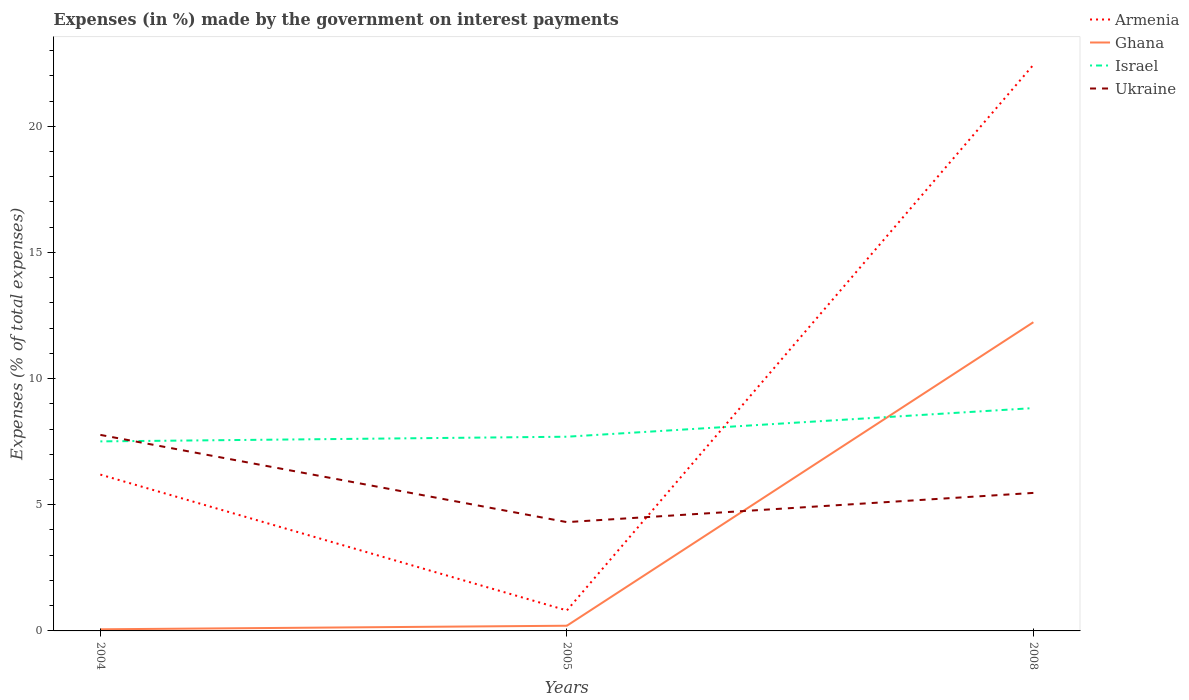How many different coloured lines are there?
Ensure brevity in your answer.  4. Across all years, what is the maximum percentage of expenses made by the government on interest payments in Armenia?
Provide a succinct answer. 0.81. What is the total percentage of expenses made by the government on interest payments in Armenia in the graph?
Provide a short and direct response. -16.24. What is the difference between the highest and the second highest percentage of expenses made by the government on interest payments in Ghana?
Make the answer very short. 12.17. Are the values on the major ticks of Y-axis written in scientific E-notation?
Provide a short and direct response. No. Where does the legend appear in the graph?
Your answer should be very brief. Top right. How many legend labels are there?
Your answer should be very brief. 4. How are the legend labels stacked?
Offer a very short reply. Vertical. What is the title of the graph?
Give a very brief answer. Expenses (in %) made by the government on interest payments. Does "Faeroe Islands" appear as one of the legend labels in the graph?
Make the answer very short. No. What is the label or title of the Y-axis?
Offer a terse response. Expenses (% of total expenses). What is the Expenses (% of total expenses) in Armenia in 2004?
Offer a terse response. 6.2. What is the Expenses (% of total expenses) in Ghana in 2004?
Ensure brevity in your answer.  0.06. What is the Expenses (% of total expenses) in Israel in 2004?
Provide a succinct answer. 7.51. What is the Expenses (% of total expenses) of Ukraine in 2004?
Keep it short and to the point. 7.77. What is the Expenses (% of total expenses) in Armenia in 2005?
Give a very brief answer. 0.81. What is the Expenses (% of total expenses) in Ghana in 2005?
Make the answer very short. 0.21. What is the Expenses (% of total expenses) in Israel in 2005?
Your response must be concise. 7.7. What is the Expenses (% of total expenses) in Ukraine in 2005?
Your response must be concise. 4.31. What is the Expenses (% of total expenses) in Armenia in 2008?
Offer a terse response. 22.44. What is the Expenses (% of total expenses) in Ghana in 2008?
Keep it short and to the point. 12.23. What is the Expenses (% of total expenses) of Israel in 2008?
Provide a short and direct response. 8.83. What is the Expenses (% of total expenses) of Ukraine in 2008?
Your answer should be compact. 5.47. Across all years, what is the maximum Expenses (% of total expenses) of Armenia?
Offer a terse response. 22.44. Across all years, what is the maximum Expenses (% of total expenses) of Ghana?
Keep it short and to the point. 12.23. Across all years, what is the maximum Expenses (% of total expenses) in Israel?
Keep it short and to the point. 8.83. Across all years, what is the maximum Expenses (% of total expenses) in Ukraine?
Provide a short and direct response. 7.77. Across all years, what is the minimum Expenses (% of total expenses) in Armenia?
Your response must be concise. 0.81. Across all years, what is the minimum Expenses (% of total expenses) of Ghana?
Your answer should be compact. 0.06. Across all years, what is the minimum Expenses (% of total expenses) in Israel?
Ensure brevity in your answer.  7.51. Across all years, what is the minimum Expenses (% of total expenses) in Ukraine?
Offer a terse response. 4.31. What is the total Expenses (% of total expenses) of Armenia in the graph?
Your answer should be compact. 29.44. What is the total Expenses (% of total expenses) of Ghana in the graph?
Give a very brief answer. 12.5. What is the total Expenses (% of total expenses) in Israel in the graph?
Give a very brief answer. 24.04. What is the total Expenses (% of total expenses) in Ukraine in the graph?
Offer a terse response. 17.55. What is the difference between the Expenses (% of total expenses) in Armenia in 2004 and that in 2005?
Offer a terse response. 5.38. What is the difference between the Expenses (% of total expenses) in Ghana in 2004 and that in 2005?
Offer a very short reply. -0.14. What is the difference between the Expenses (% of total expenses) in Israel in 2004 and that in 2005?
Provide a succinct answer. -0.19. What is the difference between the Expenses (% of total expenses) in Ukraine in 2004 and that in 2005?
Keep it short and to the point. 3.46. What is the difference between the Expenses (% of total expenses) of Armenia in 2004 and that in 2008?
Ensure brevity in your answer.  -16.24. What is the difference between the Expenses (% of total expenses) of Ghana in 2004 and that in 2008?
Provide a succinct answer. -12.17. What is the difference between the Expenses (% of total expenses) in Israel in 2004 and that in 2008?
Your response must be concise. -1.32. What is the difference between the Expenses (% of total expenses) in Ukraine in 2004 and that in 2008?
Make the answer very short. 2.3. What is the difference between the Expenses (% of total expenses) in Armenia in 2005 and that in 2008?
Provide a short and direct response. -21.62. What is the difference between the Expenses (% of total expenses) of Ghana in 2005 and that in 2008?
Your response must be concise. -12.03. What is the difference between the Expenses (% of total expenses) in Israel in 2005 and that in 2008?
Your response must be concise. -1.13. What is the difference between the Expenses (% of total expenses) of Ukraine in 2005 and that in 2008?
Offer a very short reply. -1.16. What is the difference between the Expenses (% of total expenses) of Armenia in 2004 and the Expenses (% of total expenses) of Ghana in 2005?
Your response must be concise. 5.99. What is the difference between the Expenses (% of total expenses) in Armenia in 2004 and the Expenses (% of total expenses) in Israel in 2005?
Provide a short and direct response. -1.5. What is the difference between the Expenses (% of total expenses) in Armenia in 2004 and the Expenses (% of total expenses) in Ukraine in 2005?
Ensure brevity in your answer.  1.88. What is the difference between the Expenses (% of total expenses) of Ghana in 2004 and the Expenses (% of total expenses) of Israel in 2005?
Your answer should be very brief. -7.63. What is the difference between the Expenses (% of total expenses) of Ghana in 2004 and the Expenses (% of total expenses) of Ukraine in 2005?
Your answer should be compact. -4.25. What is the difference between the Expenses (% of total expenses) of Israel in 2004 and the Expenses (% of total expenses) of Ukraine in 2005?
Offer a terse response. 3.2. What is the difference between the Expenses (% of total expenses) in Armenia in 2004 and the Expenses (% of total expenses) in Ghana in 2008?
Keep it short and to the point. -6.04. What is the difference between the Expenses (% of total expenses) of Armenia in 2004 and the Expenses (% of total expenses) of Israel in 2008?
Make the answer very short. -2.64. What is the difference between the Expenses (% of total expenses) in Armenia in 2004 and the Expenses (% of total expenses) in Ukraine in 2008?
Your answer should be very brief. 0.73. What is the difference between the Expenses (% of total expenses) in Ghana in 2004 and the Expenses (% of total expenses) in Israel in 2008?
Your answer should be compact. -8.77. What is the difference between the Expenses (% of total expenses) in Ghana in 2004 and the Expenses (% of total expenses) in Ukraine in 2008?
Offer a very short reply. -5.41. What is the difference between the Expenses (% of total expenses) of Israel in 2004 and the Expenses (% of total expenses) of Ukraine in 2008?
Offer a terse response. 2.04. What is the difference between the Expenses (% of total expenses) of Armenia in 2005 and the Expenses (% of total expenses) of Ghana in 2008?
Ensure brevity in your answer.  -11.42. What is the difference between the Expenses (% of total expenses) in Armenia in 2005 and the Expenses (% of total expenses) in Israel in 2008?
Your answer should be compact. -8.02. What is the difference between the Expenses (% of total expenses) of Armenia in 2005 and the Expenses (% of total expenses) of Ukraine in 2008?
Provide a short and direct response. -4.66. What is the difference between the Expenses (% of total expenses) in Ghana in 2005 and the Expenses (% of total expenses) in Israel in 2008?
Your answer should be compact. -8.63. What is the difference between the Expenses (% of total expenses) of Ghana in 2005 and the Expenses (% of total expenses) of Ukraine in 2008?
Provide a succinct answer. -5.26. What is the difference between the Expenses (% of total expenses) in Israel in 2005 and the Expenses (% of total expenses) in Ukraine in 2008?
Keep it short and to the point. 2.23. What is the average Expenses (% of total expenses) in Armenia per year?
Your response must be concise. 9.81. What is the average Expenses (% of total expenses) of Ghana per year?
Your response must be concise. 4.17. What is the average Expenses (% of total expenses) in Israel per year?
Offer a terse response. 8.01. What is the average Expenses (% of total expenses) in Ukraine per year?
Your response must be concise. 5.85. In the year 2004, what is the difference between the Expenses (% of total expenses) in Armenia and Expenses (% of total expenses) in Ghana?
Your answer should be very brief. 6.13. In the year 2004, what is the difference between the Expenses (% of total expenses) of Armenia and Expenses (% of total expenses) of Israel?
Your answer should be compact. -1.32. In the year 2004, what is the difference between the Expenses (% of total expenses) of Armenia and Expenses (% of total expenses) of Ukraine?
Offer a terse response. -1.57. In the year 2004, what is the difference between the Expenses (% of total expenses) in Ghana and Expenses (% of total expenses) in Israel?
Offer a very short reply. -7.45. In the year 2004, what is the difference between the Expenses (% of total expenses) in Ghana and Expenses (% of total expenses) in Ukraine?
Offer a terse response. -7.7. In the year 2004, what is the difference between the Expenses (% of total expenses) of Israel and Expenses (% of total expenses) of Ukraine?
Your answer should be very brief. -0.26. In the year 2005, what is the difference between the Expenses (% of total expenses) of Armenia and Expenses (% of total expenses) of Ghana?
Your answer should be compact. 0.61. In the year 2005, what is the difference between the Expenses (% of total expenses) of Armenia and Expenses (% of total expenses) of Israel?
Offer a terse response. -6.88. In the year 2005, what is the difference between the Expenses (% of total expenses) in Ghana and Expenses (% of total expenses) in Israel?
Your answer should be compact. -7.49. In the year 2005, what is the difference between the Expenses (% of total expenses) in Ghana and Expenses (% of total expenses) in Ukraine?
Your answer should be very brief. -4.11. In the year 2005, what is the difference between the Expenses (% of total expenses) of Israel and Expenses (% of total expenses) of Ukraine?
Provide a short and direct response. 3.38. In the year 2008, what is the difference between the Expenses (% of total expenses) of Armenia and Expenses (% of total expenses) of Ghana?
Ensure brevity in your answer.  10.2. In the year 2008, what is the difference between the Expenses (% of total expenses) in Armenia and Expenses (% of total expenses) in Israel?
Provide a succinct answer. 13.61. In the year 2008, what is the difference between the Expenses (% of total expenses) in Armenia and Expenses (% of total expenses) in Ukraine?
Your answer should be compact. 16.97. In the year 2008, what is the difference between the Expenses (% of total expenses) of Ghana and Expenses (% of total expenses) of Israel?
Your answer should be very brief. 3.4. In the year 2008, what is the difference between the Expenses (% of total expenses) of Ghana and Expenses (% of total expenses) of Ukraine?
Your answer should be very brief. 6.77. In the year 2008, what is the difference between the Expenses (% of total expenses) of Israel and Expenses (% of total expenses) of Ukraine?
Your answer should be very brief. 3.36. What is the ratio of the Expenses (% of total expenses) in Armenia in 2004 to that in 2005?
Give a very brief answer. 7.63. What is the ratio of the Expenses (% of total expenses) in Ghana in 2004 to that in 2005?
Offer a terse response. 0.31. What is the ratio of the Expenses (% of total expenses) of Israel in 2004 to that in 2005?
Ensure brevity in your answer.  0.98. What is the ratio of the Expenses (% of total expenses) in Ukraine in 2004 to that in 2005?
Give a very brief answer. 1.8. What is the ratio of the Expenses (% of total expenses) in Armenia in 2004 to that in 2008?
Keep it short and to the point. 0.28. What is the ratio of the Expenses (% of total expenses) of Ghana in 2004 to that in 2008?
Make the answer very short. 0.01. What is the ratio of the Expenses (% of total expenses) in Israel in 2004 to that in 2008?
Your answer should be compact. 0.85. What is the ratio of the Expenses (% of total expenses) of Ukraine in 2004 to that in 2008?
Provide a succinct answer. 1.42. What is the ratio of the Expenses (% of total expenses) of Armenia in 2005 to that in 2008?
Keep it short and to the point. 0.04. What is the ratio of the Expenses (% of total expenses) of Ghana in 2005 to that in 2008?
Keep it short and to the point. 0.02. What is the ratio of the Expenses (% of total expenses) in Israel in 2005 to that in 2008?
Make the answer very short. 0.87. What is the ratio of the Expenses (% of total expenses) of Ukraine in 2005 to that in 2008?
Provide a succinct answer. 0.79. What is the difference between the highest and the second highest Expenses (% of total expenses) of Armenia?
Offer a very short reply. 16.24. What is the difference between the highest and the second highest Expenses (% of total expenses) of Ghana?
Keep it short and to the point. 12.03. What is the difference between the highest and the second highest Expenses (% of total expenses) of Israel?
Provide a short and direct response. 1.13. What is the difference between the highest and the second highest Expenses (% of total expenses) of Ukraine?
Make the answer very short. 2.3. What is the difference between the highest and the lowest Expenses (% of total expenses) in Armenia?
Give a very brief answer. 21.62. What is the difference between the highest and the lowest Expenses (% of total expenses) in Ghana?
Your response must be concise. 12.17. What is the difference between the highest and the lowest Expenses (% of total expenses) of Israel?
Offer a very short reply. 1.32. What is the difference between the highest and the lowest Expenses (% of total expenses) in Ukraine?
Make the answer very short. 3.46. 